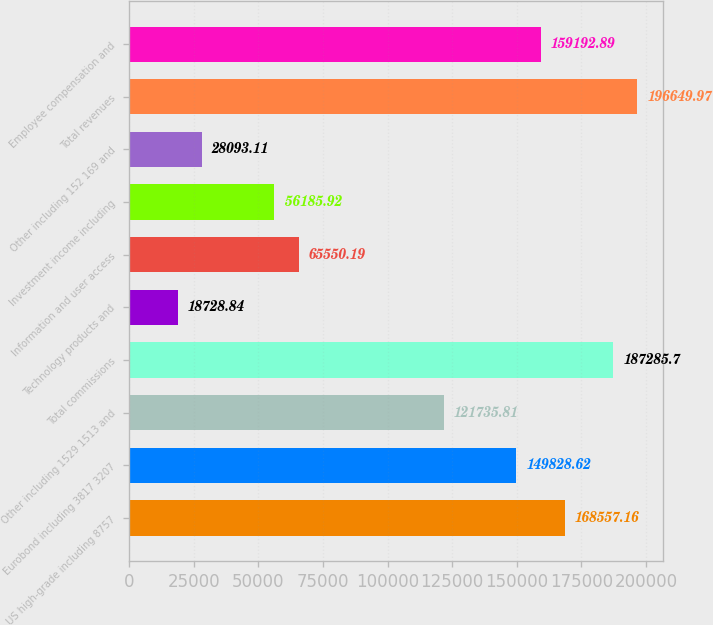<chart> <loc_0><loc_0><loc_500><loc_500><bar_chart><fcel>US high-grade including 8757<fcel>Eurobond including 3817 3207<fcel>Other including 1529 1513 and<fcel>Total commissions<fcel>Technology products and<fcel>Information and user access<fcel>Investment income including<fcel>Other including 152 169 and<fcel>Total revenues<fcel>Employee compensation and<nl><fcel>168557<fcel>149829<fcel>121736<fcel>187286<fcel>18728.8<fcel>65550.2<fcel>56185.9<fcel>28093.1<fcel>196650<fcel>159193<nl></chart> 